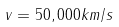<formula> <loc_0><loc_0><loc_500><loc_500>v = 5 0 , 0 0 0 k m / s</formula> 